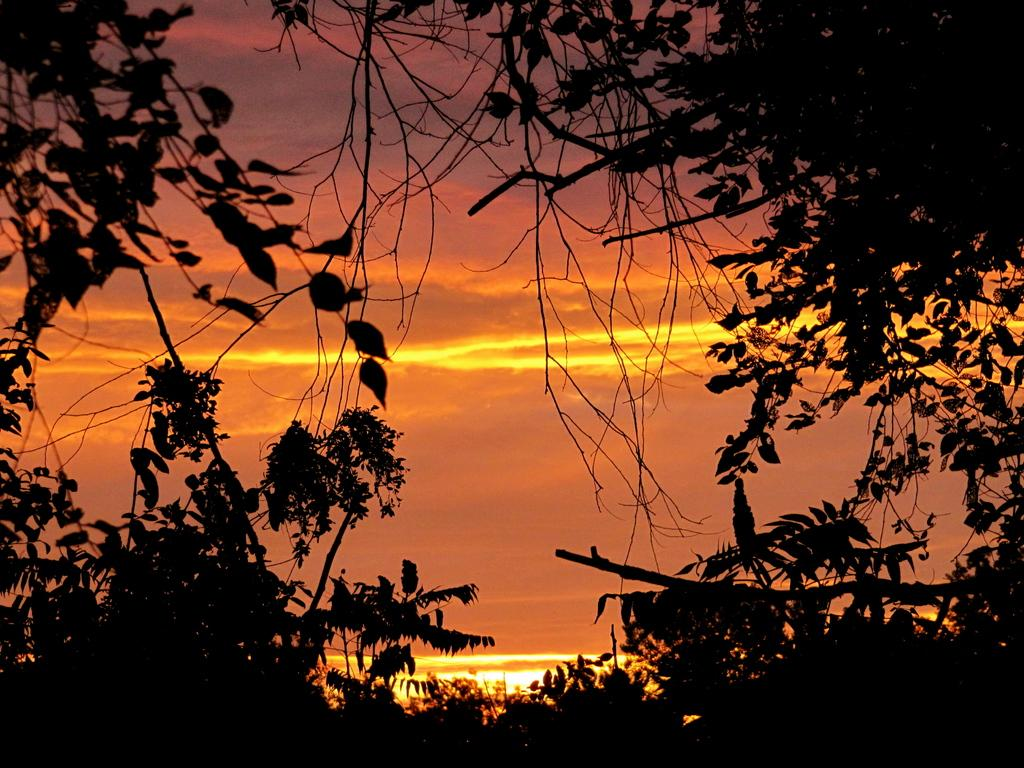What can be seen in the background of the image? The sky is visible in the background of the image. What type of vegetation is present in the image? There are trees in the image. What color are the leaves on the trees? Green leaves are present in the image. What part of the trees can be seen in the image? The branches of the trees are visible in the image. What type of ship can be seen sailing in the image? There is no ship present in the image; it features trees and a sky background. What type of act is being performed by the trees in the image? Trees are not capable of performing acts, as they are inanimate objects. 